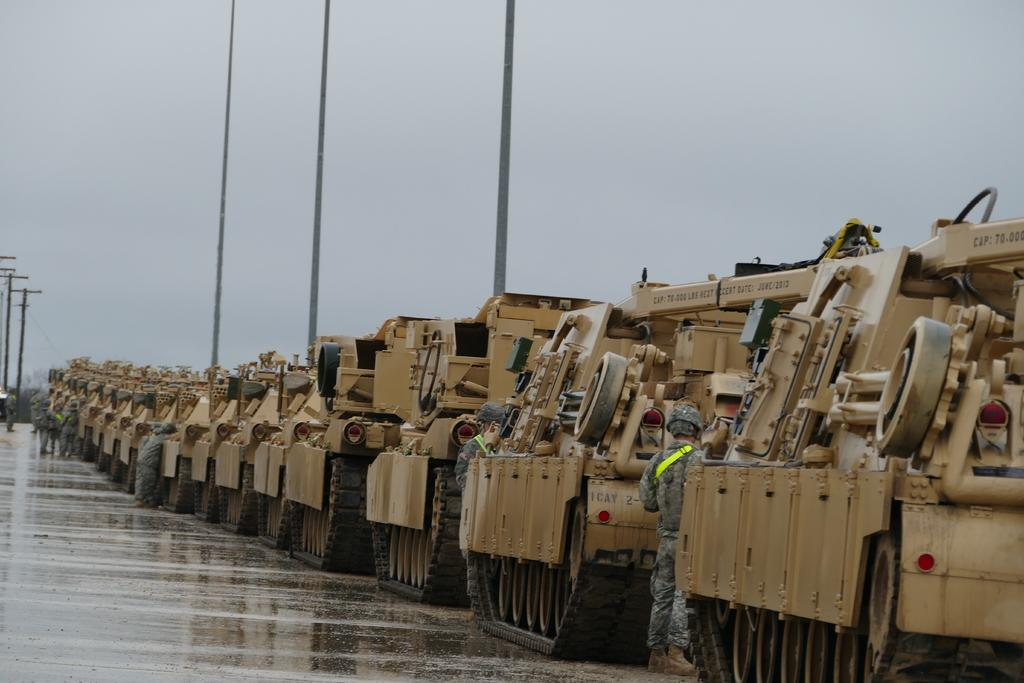Who or what can be seen in the image? There are people in the image. What else is present in the image besides people? There are vehicles on the road and poles in the image. What can be seen in the background of the image? The sky is visible in the background of the image. What type of feeling can be seen on the credit stick in the image? There is no credit stick present in the image, and therefore no such feeling can be observed. 